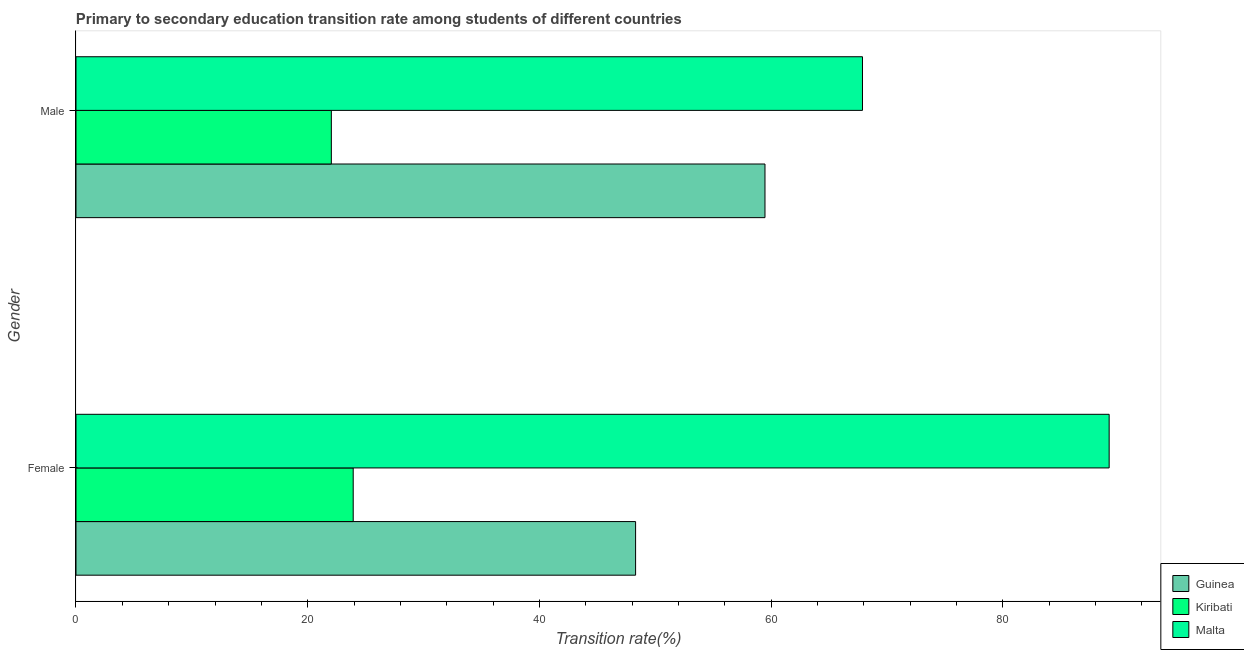How many different coloured bars are there?
Offer a very short reply. 3. How many groups of bars are there?
Make the answer very short. 2. Are the number of bars per tick equal to the number of legend labels?
Your response must be concise. Yes. What is the transition rate among female students in Kiribati?
Provide a succinct answer. 23.93. Across all countries, what is the maximum transition rate among male students?
Provide a succinct answer. 67.88. Across all countries, what is the minimum transition rate among male students?
Your answer should be very brief. 22.04. In which country was the transition rate among female students maximum?
Keep it short and to the point. Malta. In which country was the transition rate among male students minimum?
Your answer should be compact. Kiribati. What is the total transition rate among female students in the graph?
Keep it short and to the point. 161.4. What is the difference between the transition rate among male students in Kiribati and that in Guinea?
Offer a very short reply. -37.43. What is the difference between the transition rate among male students in Guinea and the transition rate among female students in Malta?
Provide a succinct answer. -29.71. What is the average transition rate among male students per country?
Give a very brief answer. 49.8. What is the difference between the transition rate among female students and transition rate among male students in Malta?
Offer a very short reply. 21.29. In how many countries, is the transition rate among male students greater than 72 %?
Keep it short and to the point. 0. What is the ratio of the transition rate among female students in Kiribati to that in Malta?
Make the answer very short. 0.27. What does the 2nd bar from the top in Male represents?
Your answer should be very brief. Kiribati. What does the 1st bar from the bottom in Female represents?
Provide a succinct answer. Guinea. How many bars are there?
Offer a very short reply. 6. Are all the bars in the graph horizontal?
Your answer should be very brief. Yes. How many countries are there in the graph?
Provide a succinct answer. 3. Are the values on the major ticks of X-axis written in scientific E-notation?
Provide a short and direct response. No. Does the graph contain any zero values?
Ensure brevity in your answer.  No. Does the graph contain grids?
Provide a short and direct response. No. How many legend labels are there?
Provide a succinct answer. 3. How are the legend labels stacked?
Ensure brevity in your answer.  Vertical. What is the title of the graph?
Your answer should be very brief. Primary to secondary education transition rate among students of different countries. Does "Papua New Guinea" appear as one of the legend labels in the graph?
Offer a terse response. No. What is the label or title of the X-axis?
Keep it short and to the point. Transition rate(%). What is the Transition rate(%) of Guinea in Female?
Offer a terse response. 48.3. What is the Transition rate(%) in Kiribati in Female?
Give a very brief answer. 23.93. What is the Transition rate(%) of Malta in Female?
Your response must be concise. 89.17. What is the Transition rate(%) in Guinea in Male?
Your answer should be very brief. 59.47. What is the Transition rate(%) of Kiribati in Male?
Make the answer very short. 22.04. What is the Transition rate(%) in Malta in Male?
Your answer should be very brief. 67.88. Across all Gender, what is the maximum Transition rate(%) of Guinea?
Your response must be concise. 59.47. Across all Gender, what is the maximum Transition rate(%) of Kiribati?
Give a very brief answer. 23.93. Across all Gender, what is the maximum Transition rate(%) in Malta?
Provide a succinct answer. 89.17. Across all Gender, what is the minimum Transition rate(%) in Guinea?
Keep it short and to the point. 48.3. Across all Gender, what is the minimum Transition rate(%) of Kiribati?
Offer a terse response. 22.04. Across all Gender, what is the minimum Transition rate(%) of Malta?
Offer a terse response. 67.88. What is the total Transition rate(%) of Guinea in the graph?
Ensure brevity in your answer.  107.77. What is the total Transition rate(%) of Kiribati in the graph?
Make the answer very short. 45.97. What is the total Transition rate(%) of Malta in the graph?
Provide a succinct answer. 157.06. What is the difference between the Transition rate(%) of Guinea in Female and that in Male?
Your answer should be very brief. -11.17. What is the difference between the Transition rate(%) in Kiribati in Female and that in Male?
Keep it short and to the point. 1.89. What is the difference between the Transition rate(%) of Malta in Female and that in Male?
Provide a succinct answer. 21.29. What is the difference between the Transition rate(%) in Guinea in Female and the Transition rate(%) in Kiribati in Male?
Your answer should be compact. 26.26. What is the difference between the Transition rate(%) in Guinea in Female and the Transition rate(%) in Malta in Male?
Provide a succinct answer. -19.58. What is the difference between the Transition rate(%) in Kiribati in Female and the Transition rate(%) in Malta in Male?
Your response must be concise. -43.96. What is the average Transition rate(%) in Guinea per Gender?
Provide a succinct answer. 53.88. What is the average Transition rate(%) of Kiribati per Gender?
Your answer should be very brief. 22.98. What is the average Transition rate(%) in Malta per Gender?
Make the answer very short. 78.53. What is the difference between the Transition rate(%) of Guinea and Transition rate(%) of Kiribati in Female?
Give a very brief answer. 24.37. What is the difference between the Transition rate(%) of Guinea and Transition rate(%) of Malta in Female?
Offer a terse response. -40.87. What is the difference between the Transition rate(%) of Kiribati and Transition rate(%) of Malta in Female?
Your answer should be very brief. -65.25. What is the difference between the Transition rate(%) of Guinea and Transition rate(%) of Kiribati in Male?
Provide a short and direct response. 37.43. What is the difference between the Transition rate(%) in Guinea and Transition rate(%) in Malta in Male?
Provide a short and direct response. -8.42. What is the difference between the Transition rate(%) in Kiribati and Transition rate(%) in Malta in Male?
Give a very brief answer. -45.84. What is the ratio of the Transition rate(%) in Guinea in Female to that in Male?
Offer a very short reply. 0.81. What is the ratio of the Transition rate(%) in Kiribati in Female to that in Male?
Give a very brief answer. 1.09. What is the ratio of the Transition rate(%) in Malta in Female to that in Male?
Provide a succinct answer. 1.31. What is the difference between the highest and the second highest Transition rate(%) in Guinea?
Ensure brevity in your answer.  11.17. What is the difference between the highest and the second highest Transition rate(%) in Kiribati?
Your response must be concise. 1.89. What is the difference between the highest and the second highest Transition rate(%) in Malta?
Your answer should be compact. 21.29. What is the difference between the highest and the lowest Transition rate(%) in Guinea?
Give a very brief answer. 11.17. What is the difference between the highest and the lowest Transition rate(%) of Kiribati?
Offer a terse response. 1.89. What is the difference between the highest and the lowest Transition rate(%) of Malta?
Provide a short and direct response. 21.29. 